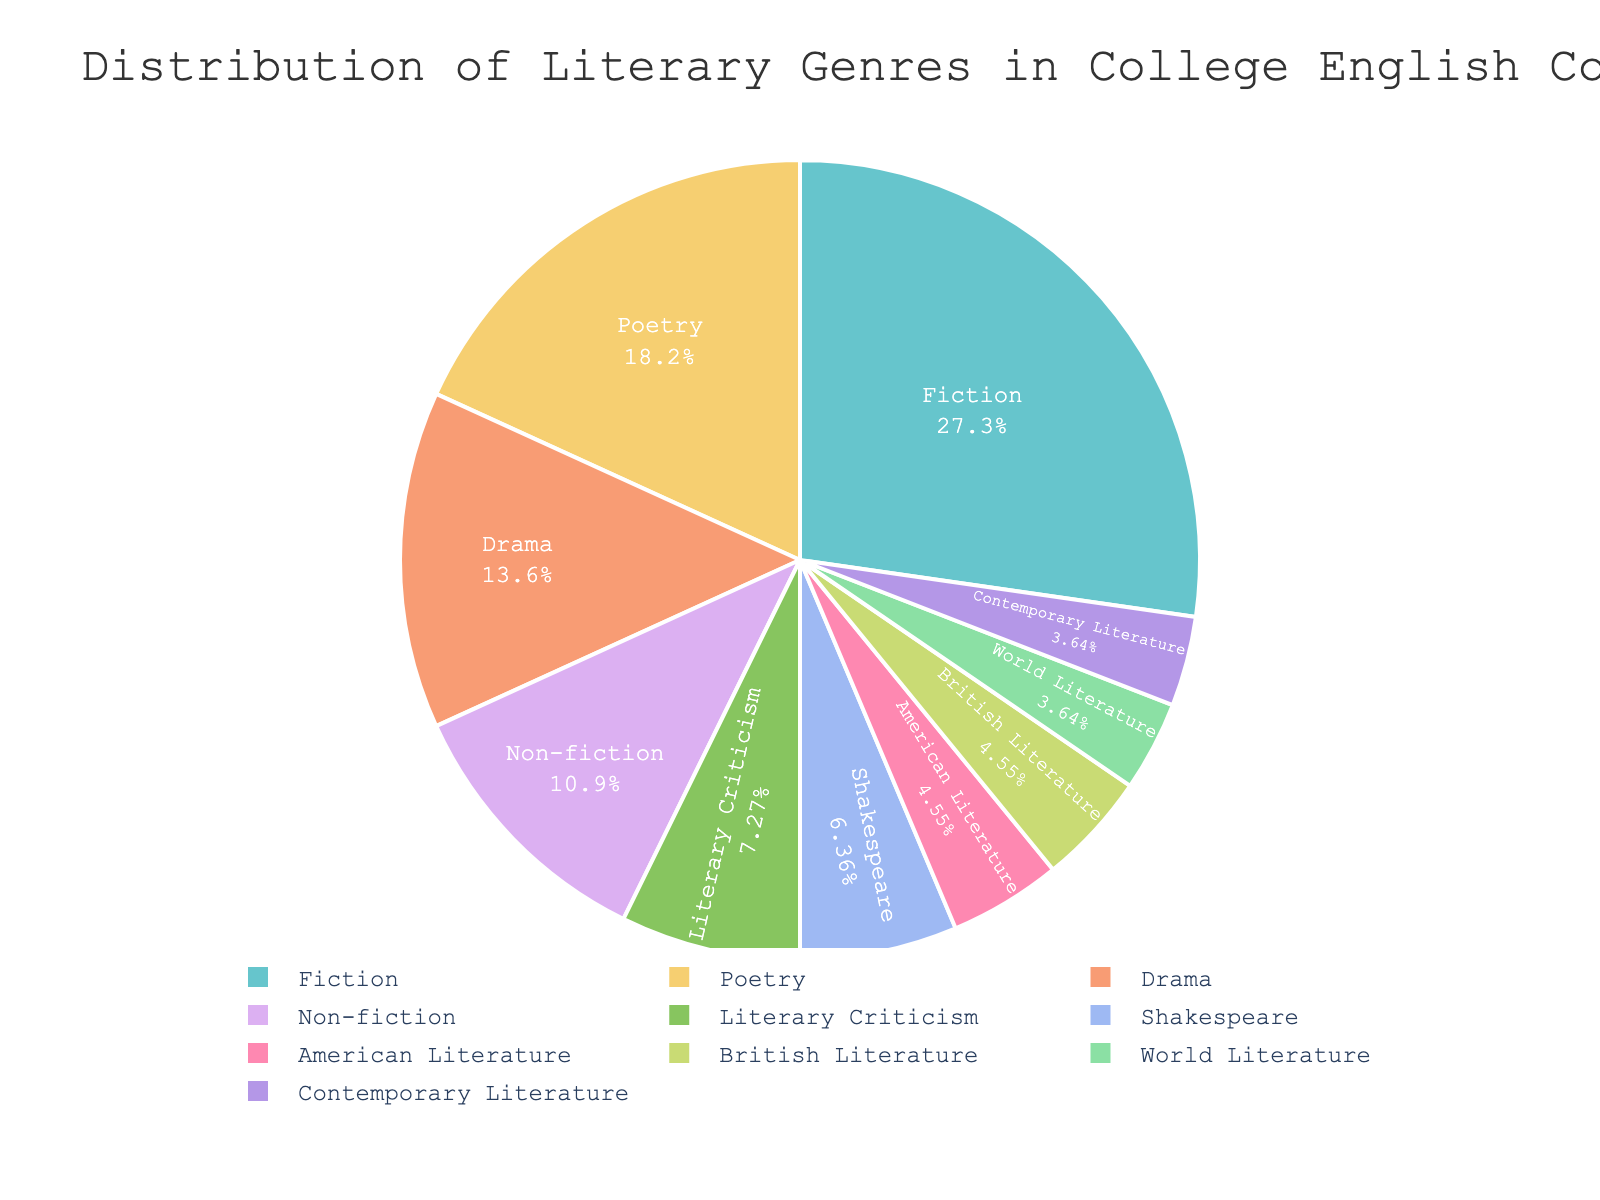Which genre has the highest percentage in the distribution? The pie chart shows that Fiction has the largest slice, indicating it has the highest percentage.
Answer: Fiction Which two genres have the smallest percentages, and what are those percentages? Observing the pie chart, the slices for World Literature and Contemporary Literature are the smallest. Both have percentages of 4%.
Answer: World Literature and Contemporary Literature, 4% What is the combined percentage of Fiction and Poetry? According to the chart, Fiction’s percentage is 30% and Poetry’s is 20%. Adding these together: 30% + 20% = 50%.
Answer: 50% Which genre represents approximately half of the total percentage of Fiction? The percentage of Fiction is 30%. Half of 30% is 15%, which is the percentage for Drama.
Answer: Drama Is the percentage of Non-fiction greater than, less than, or equal to the combined percentage of American Literature and British Literature? Non-fiction is 12%. American Literature and British Literature are each 5%, giving a combined percentage of 5% + 5% = 10%. 12% is greater than 10%.
Answer: Greater than What is the difference in percentage between the genres with the highest and lowest representation? Fiction has the highest percentage (30%) and both World Literature and Contemporary Literature have the lowest (4%). The difference is 30% - 4% = 26%.
Answer: 26% How many genres have a percentage lower than 10%? The genres below 10% are Literary Criticism (8%), Shakespeare (7%), American Literature (5%), British Literature (5%), World Literature (4%), and Contemporary Literature (4%). Counting these, there are six genres.
Answer: 6 What is the average percentage of Drama, Non-fiction, and Shakespeare? Drama is 15%, Non-fiction is 12%, and Shakespeare is 7%. The average is calculated as (15% + 12% + 7%) / 3 = 34% / 3 = 11.33%.
Answer: 11.33% Which genre that is studied in college English courses has a percentage close to the sum of Literary Criticism and Shakespeare? Literary Criticism is 8% and Shakespeare is 7%; their sum is 15%. Drama also has a percentage of 15%, which is close to this sum.
Answer: Drama What is the combined percentage of all genres excluding Fiction? First, calculate the total percentage of all genres (should be 100%). Fiction is 30%, so the combined percentage of all other genres is 100% - 30% = 70%.
Answer: 70% 